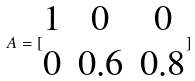Convert formula to latex. <formula><loc_0><loc_0><loc_500><loc_500>A = [ \begin{matrix} 1 & 0 & 0 \\ 0 & 0 . 6 & 0 . 8 \end{matrix} ]</formula> 